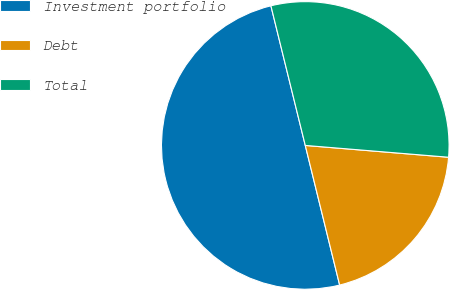Convert chart. <chart><loc_0><loc_0><loc_500><loc_500><pie_chart><fcel>Investment portfolio<fcel>Debt<fcel>Total<nl><fcel>50.0%<fcel>19.85%<fcel>30.15%<nl></chart> 